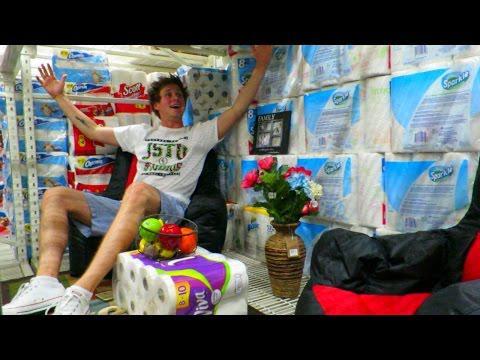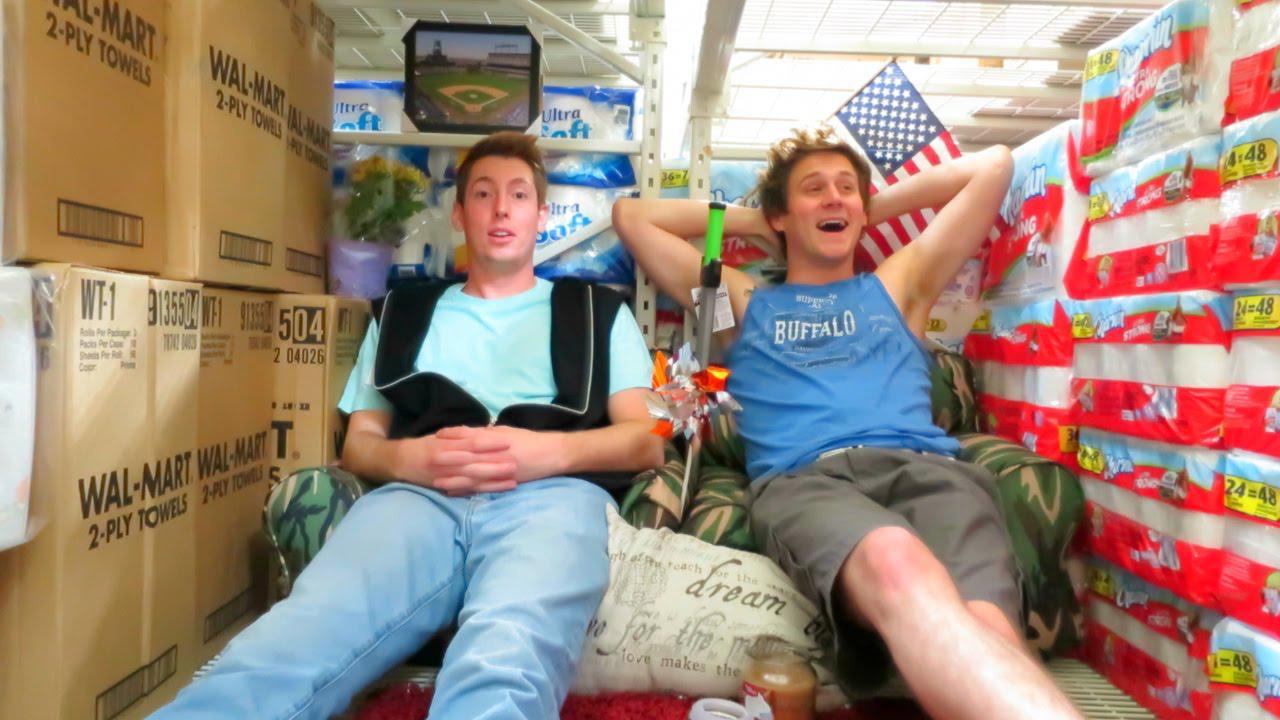The first image is the image on the left, the second image is the image on the right. For the images displayed, is the sentence "A single person sits nears piles of paper goods in the image on the right." factually correct? Answer yes or no. No. 